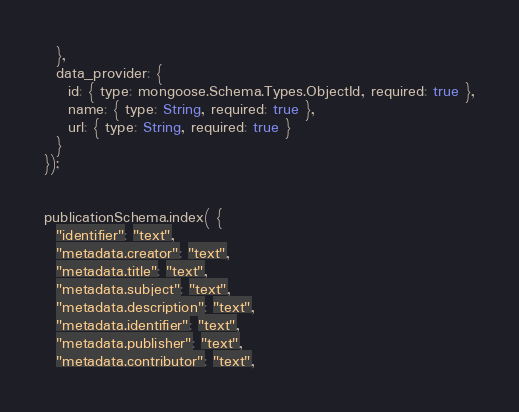<code> <loc_0><loc_0><loc_500><loc_500><_JavaScript_>  },
  data_provider: {
    id: { type: mongoose.Schema.Types.ObjectId, required: true },
    name: { type: String, required: true },
    url: { type: String, required: true }
  }
});


publicationSchema.index( { 
  "identifier": "text",
  "metadata.creator": "text",
  "metadata.title": "text",
  "metadata.subject": "text",
  "metadata.description": "text",
  "metadata.identifier": "text",
  "metadata.publisher": "text",
  "metadata.contributor": "text",</code> 